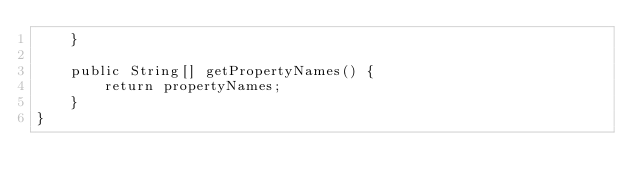<code> <loc_0><loc_0><loc_500><loc_500><_Java_>    }

    public String[] getPropertyNames() {
        return propertyNames;
    }
}
</code> 